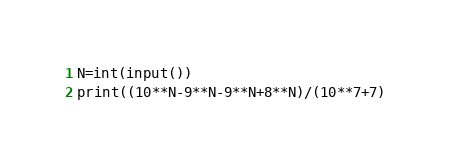<code> <loc_0><loc_0><loc_500><loc_500><_Python_>N=int(input())
print((10**N-9**N-9**N+8**N)/(10**7+7)</code> 